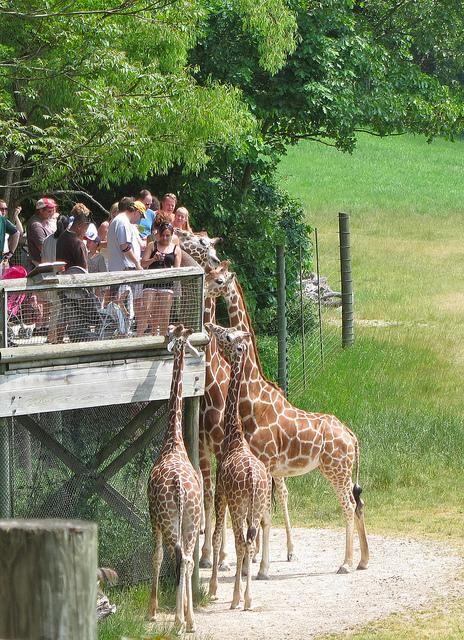Which giraffe left to right has the best chance of getting petted? Please explain your reasoning. very back. The giraffe around the corner with its neck closest to the people and highest reaching has the best chance of getting petted. 